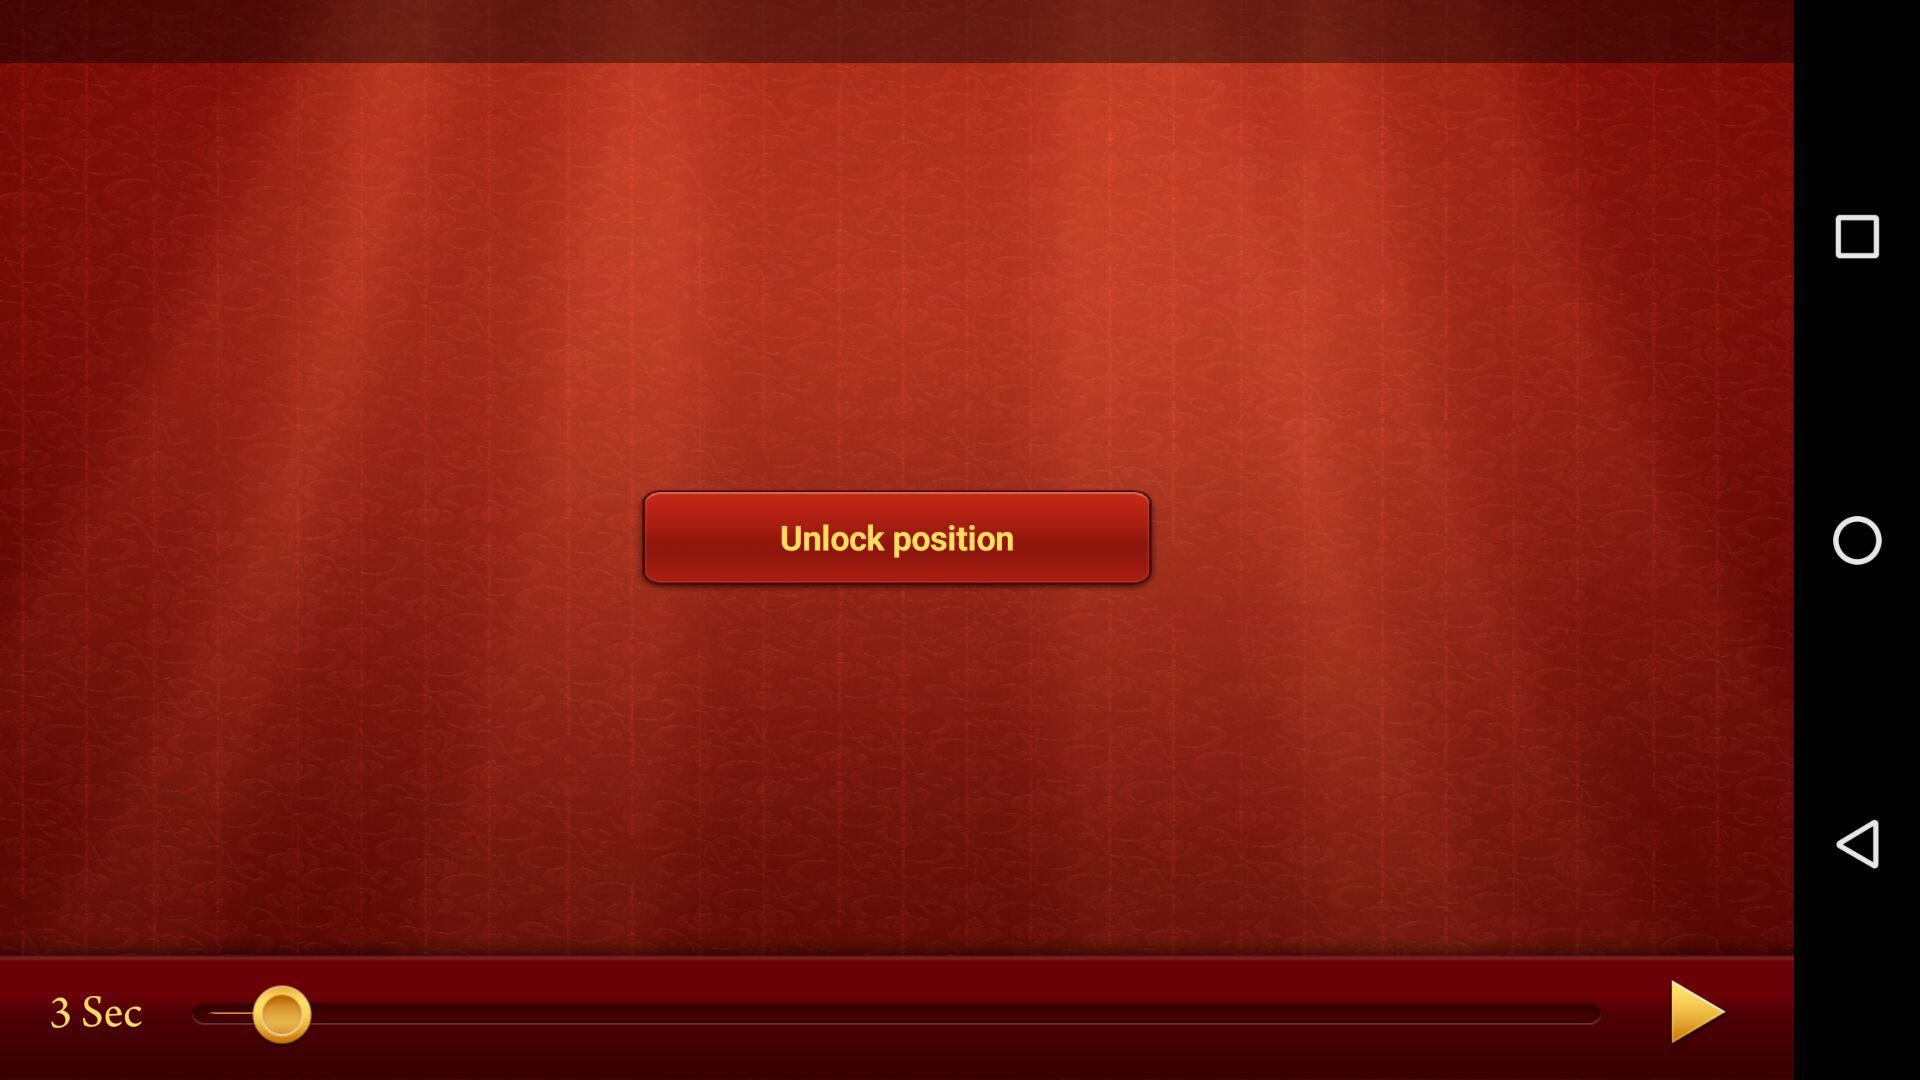What is the version of the application? The version is 3.1.12. 